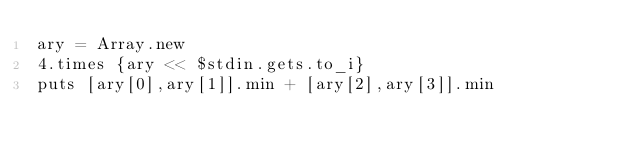Convert code to text. <code><loc_0><loc_0><loc_500><loc_500><_Ruby_>ary = Array.new
4.times {ary << $stdin.gets.to_i}
puts [ary[0],ary[1]].min + [ary[2],ary[3]].min</code> 